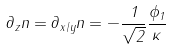Convert formula to latex. <formula><loc_0><loc_0><loc_500><loc_500>\partial _ { z } n = \partial _ { x / y } n = - \frac { 1 } { \sqrt { 2 } } \frac { \phi _ { 1 } } { \kappa }</formula> 